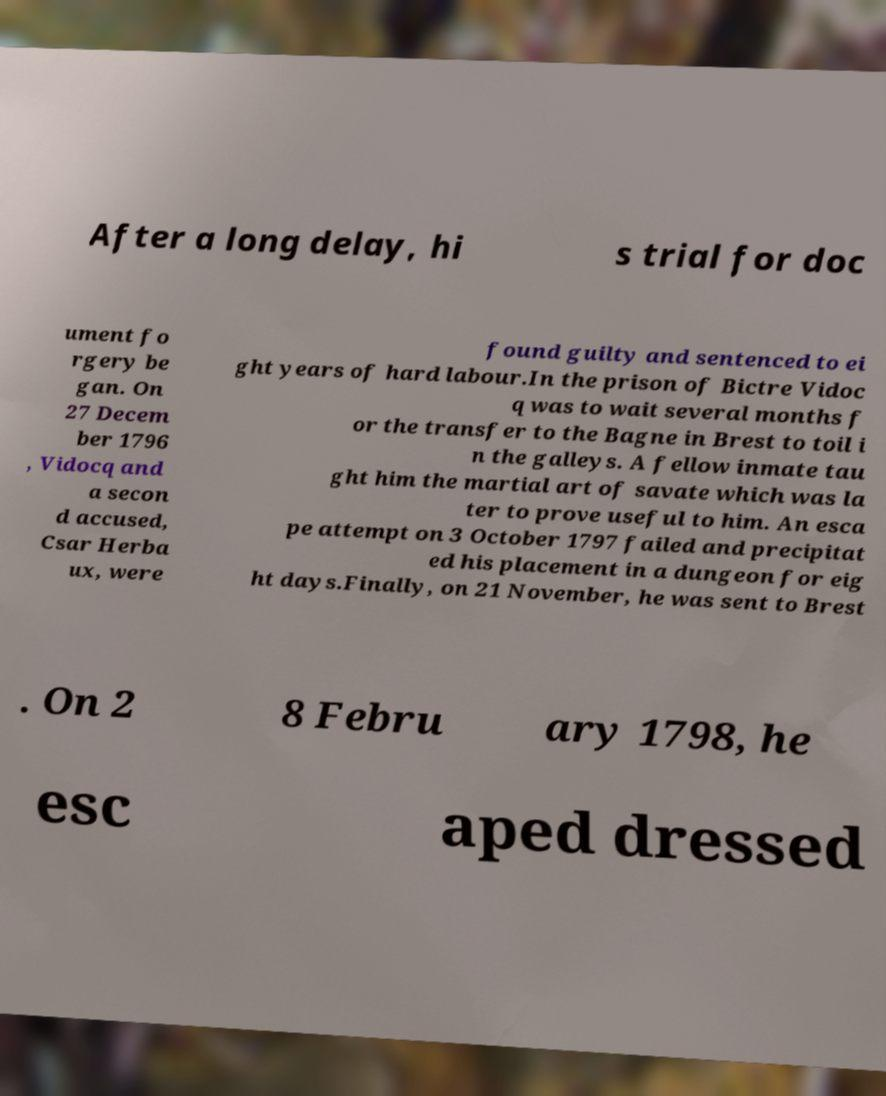Can you accurately transcribe the text from the provided image for me? After a long delay, hi s trial for doc ument fo rgery be gan. On 27 Decem ber 1796 , Vidocq and a secon d accused, Csar Herba ux, were found guilty and sentenced to ei ght years of hard labour.In the prison of Bictre Vidoc q was to wait several months f or the transfer to the Bagne in Brest to toil i n the galleys. A fellow inmate tau ght him the martial art of savate which was la ter to prove useful to him. An esca pe attempt on 3 October 1797 failed and precipitat ed his placement in a dungeon for eig ht days.Finally, on 21 November, he was sent to Brest . On 2 8 Febru ary 1798, he esc aped dressed 